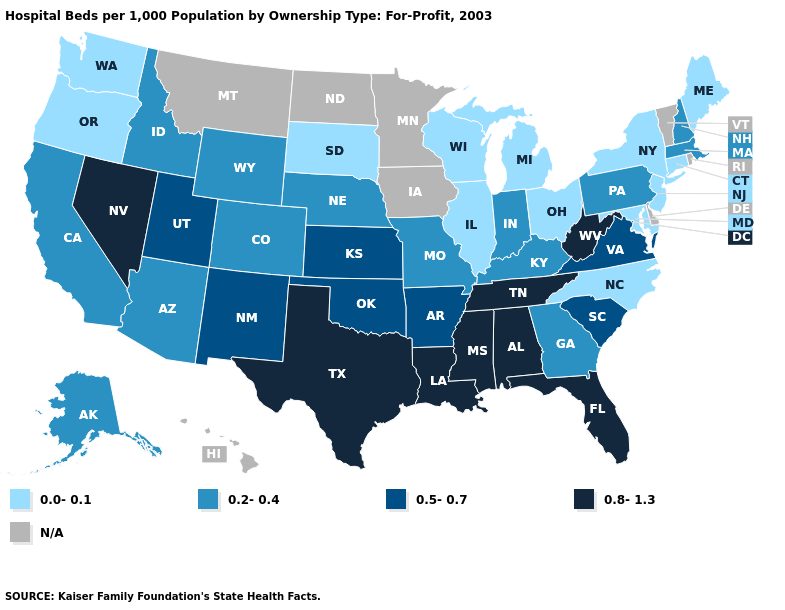What is the lowest value in the MidWest?
Keep it brief. 0.0-0.1. Name the states that have a value in the range 0.5-0.7?
Write a very short answer. Arkansas, Kansas, New Mexico, Oklahoma, South Carolina, Utah, Virginia. What is the highest value in the MidWest ?
Keep it brief. 0.5-0.7. Name the states that have a value in the range 0.0-0.1?
Answer briefly. Connecticut, Illinois, Maine, Maryland, Michigan, New Jersey, New York, North Carolina, Ohio, Oregon, South Dakota, Washington, Wisconsin. Which states hav the highest value in the South?
Keep it brief. Alabama, Florida, Louisiana, Mississippi, Tennessee, Texas, West Virginia. Which states have the highest value in the USA?
Give a very brief answer. Alabama, Florida, Louisiana, Mississippi, Nevada, Tennessee, Texas, West Virginia. What is the value of Pennsylvania?
Short answer required. 0.2-0.4. How many symbols are there in the legend?
Concise answer only. 5. What is the value of Mississippi?
Be succinct. 0.8-1.3. Name the states that have a value in the range 0.2-0.4?
Short answer required. Alaska, Arizona, California, Colorado, Georgia, Idaho, Indiana, Kentucky, Massachusetts, Missouri, Nebraska, New Hampshire, Pennsylvania, Wyoming. Which states have the lowest value in the USA?
Write a very short answer. Connecticut, Illinois, Maine, Maryland, Michigan, New Jersey, New York, North Carolina, Ohio, Oregon, South Dakota, Washington, Wisconsin. Name the states that have a value in the range 0.8-1.3?
Be succinct. Alabama, Florida, Louisiana, Mississippi, Nevada, Tennessee, Texas, West Virginia. 